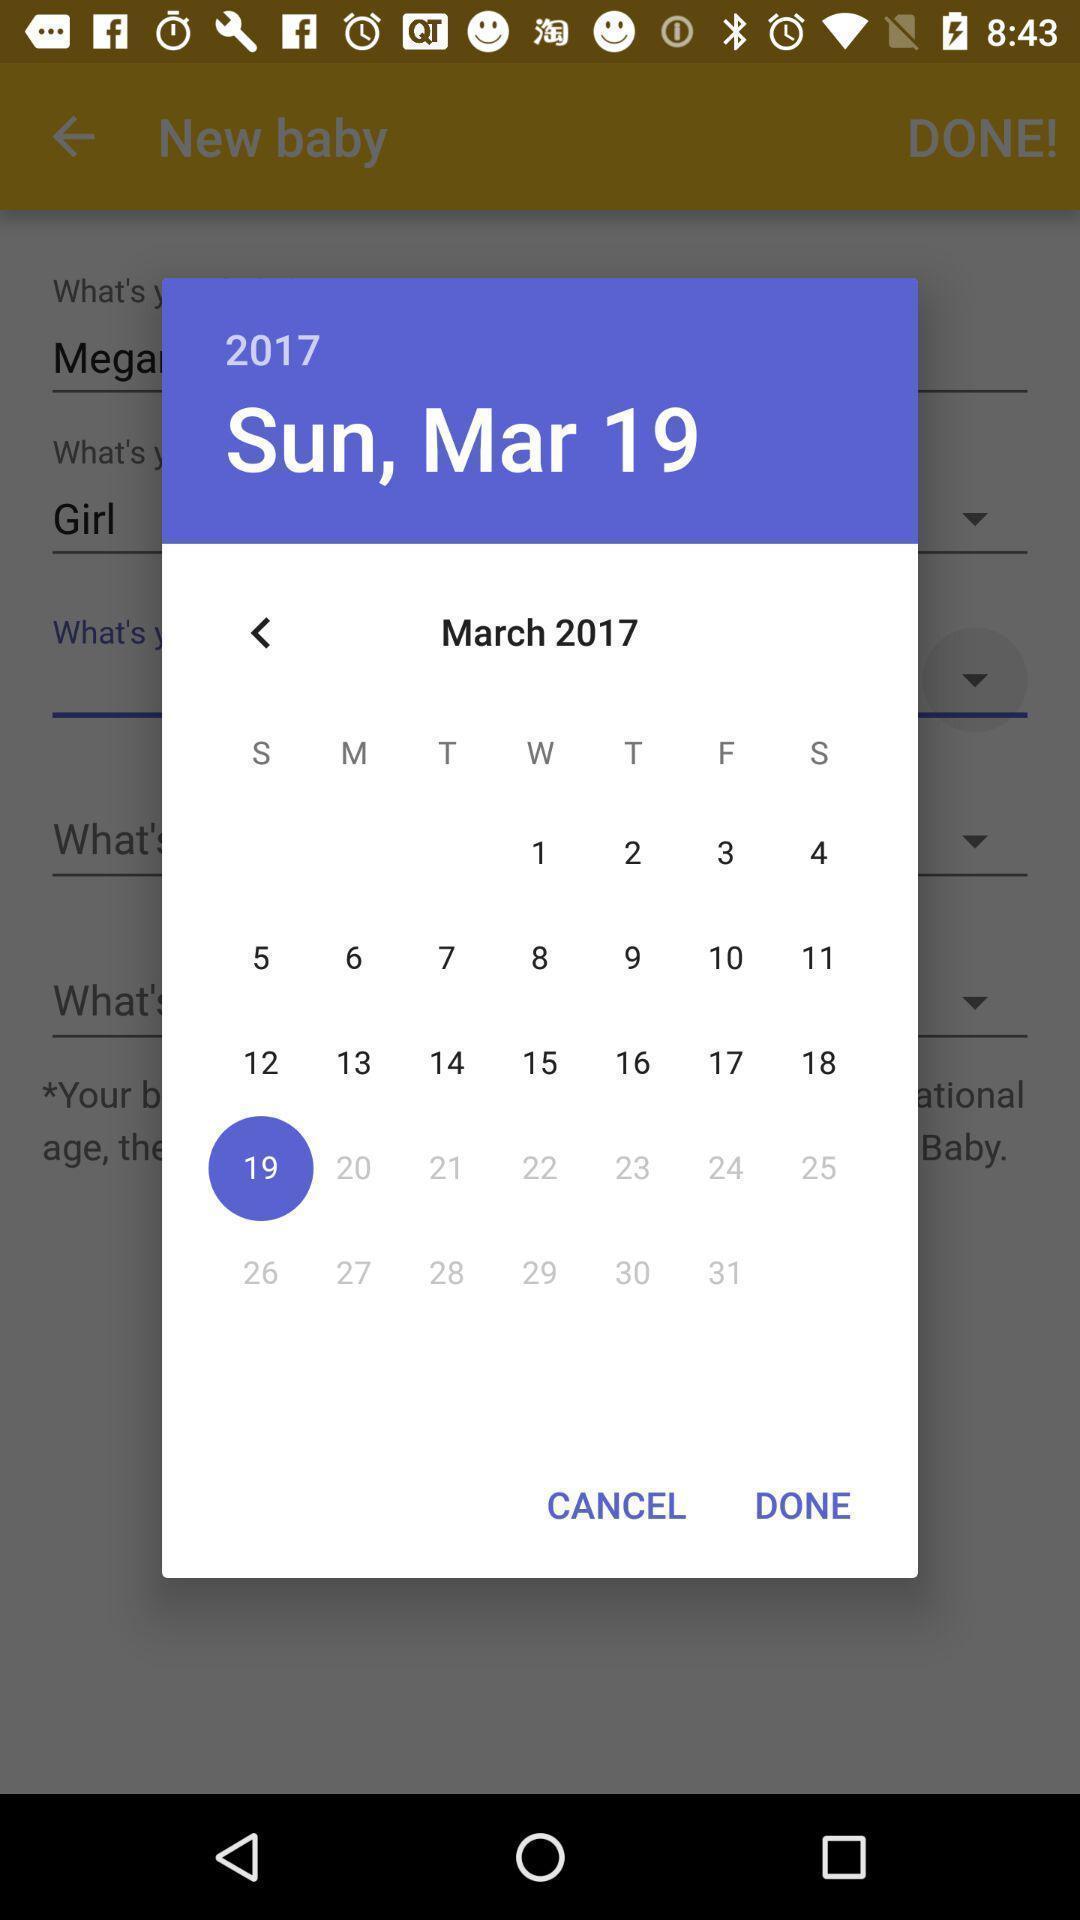Provide a textual representation of this image. Pop-up showing to select date. 